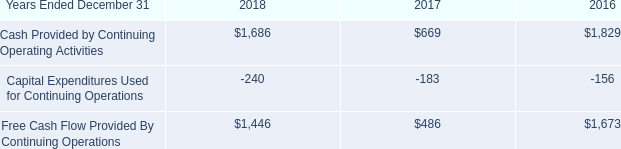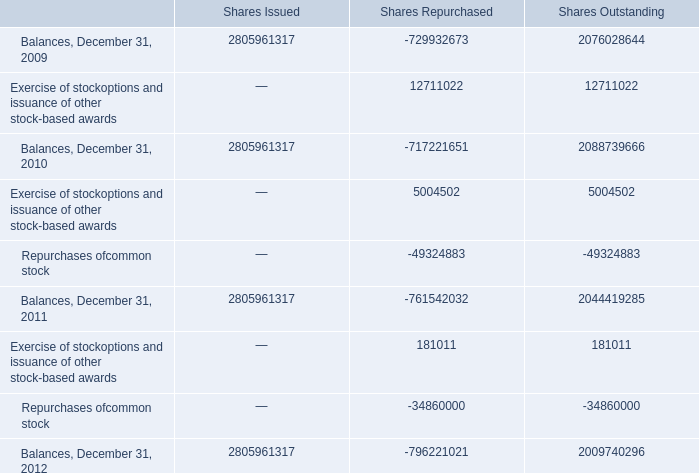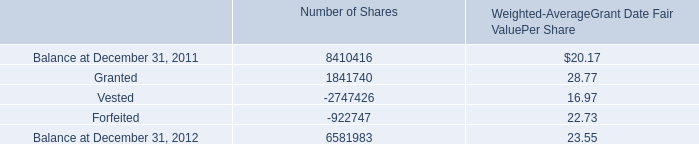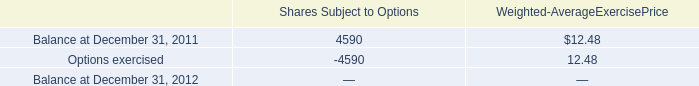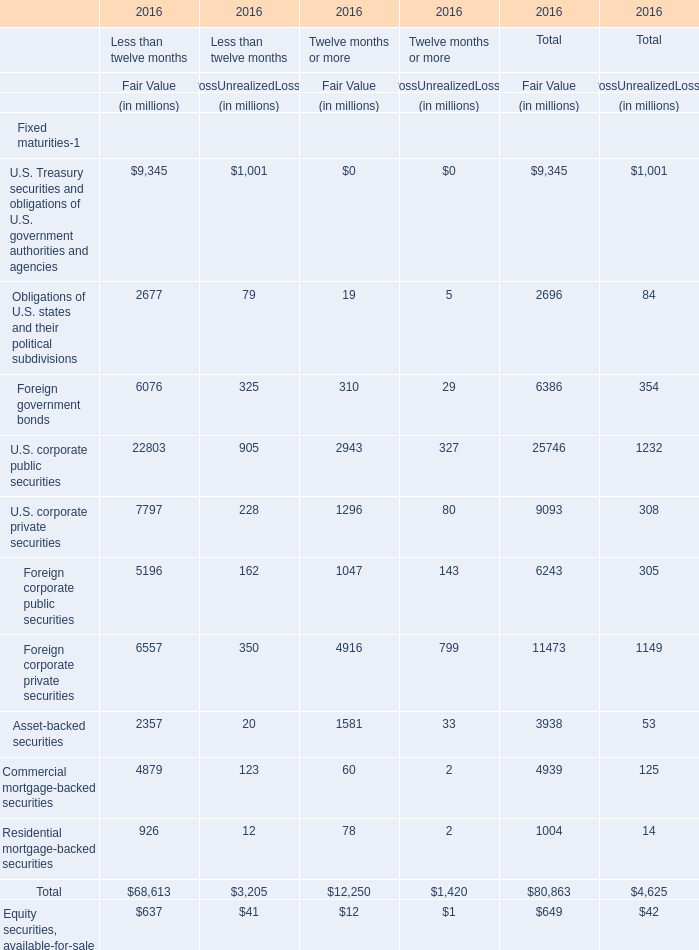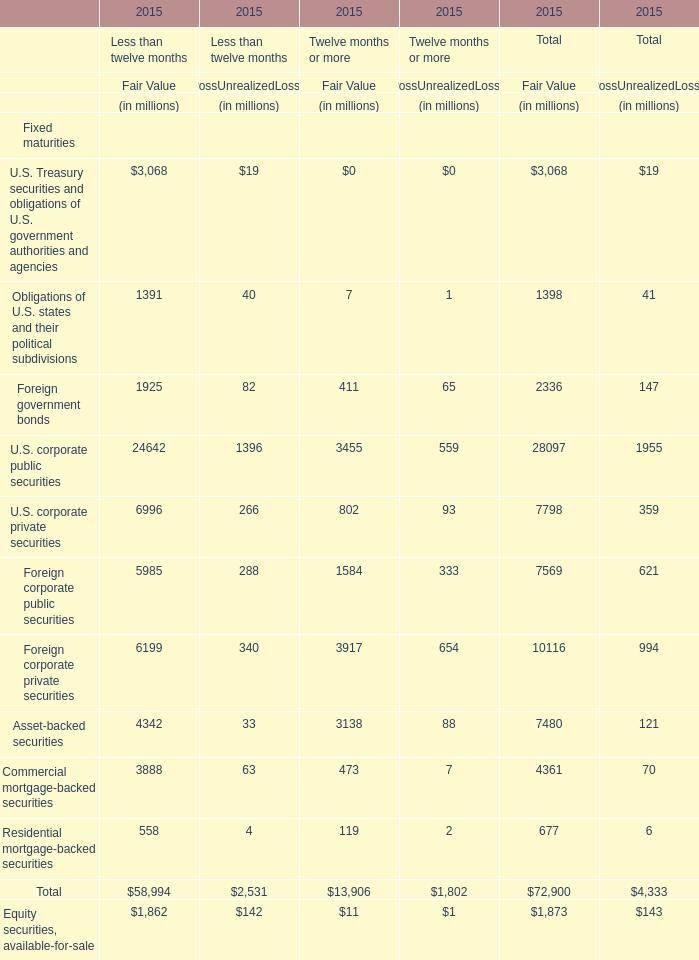What is the ratio of Granted for Number of Shares to the Options exercised for Shares Subject to Options in 2011? 
Computations: (1841740 / -4590)
Answer: -401.25054. 